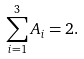<formula> <loc_0><loc_0><loc_500><loc_500>\sum _ { i = 1 } ^ { 3 } A _ { i } = 2 .</formula> 